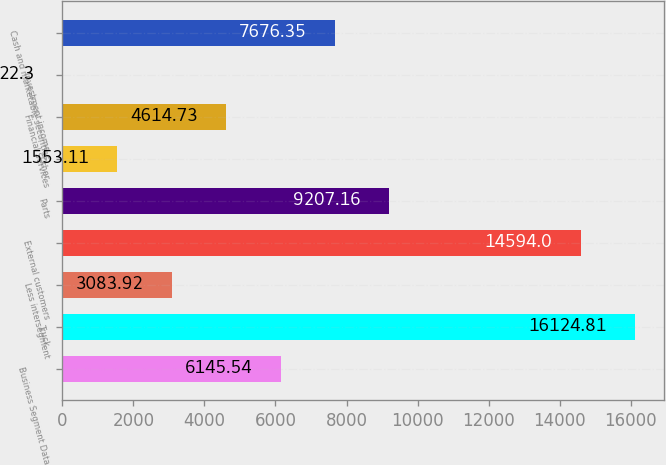Convert chart to OTSL. <chart><loc_0><loc_0><loc_500><loc_500><bar_chart><fcel>Business Segment Data<fcel>Truck<fcel>Less intersegment<fcel>External customers<fcel>Parts<fcel>Other<fcel>Financial Services<fcel>Investment income<fcel>Cash and marketable securities<nl><fcel>6145.54<fcel>16124.8<fcel>3083.92<fcel>14594<fcel>9207.16<fcel>1553.11<fcel>4614.73<fcel>22.3<fcel>7676.35<nl></chart> 